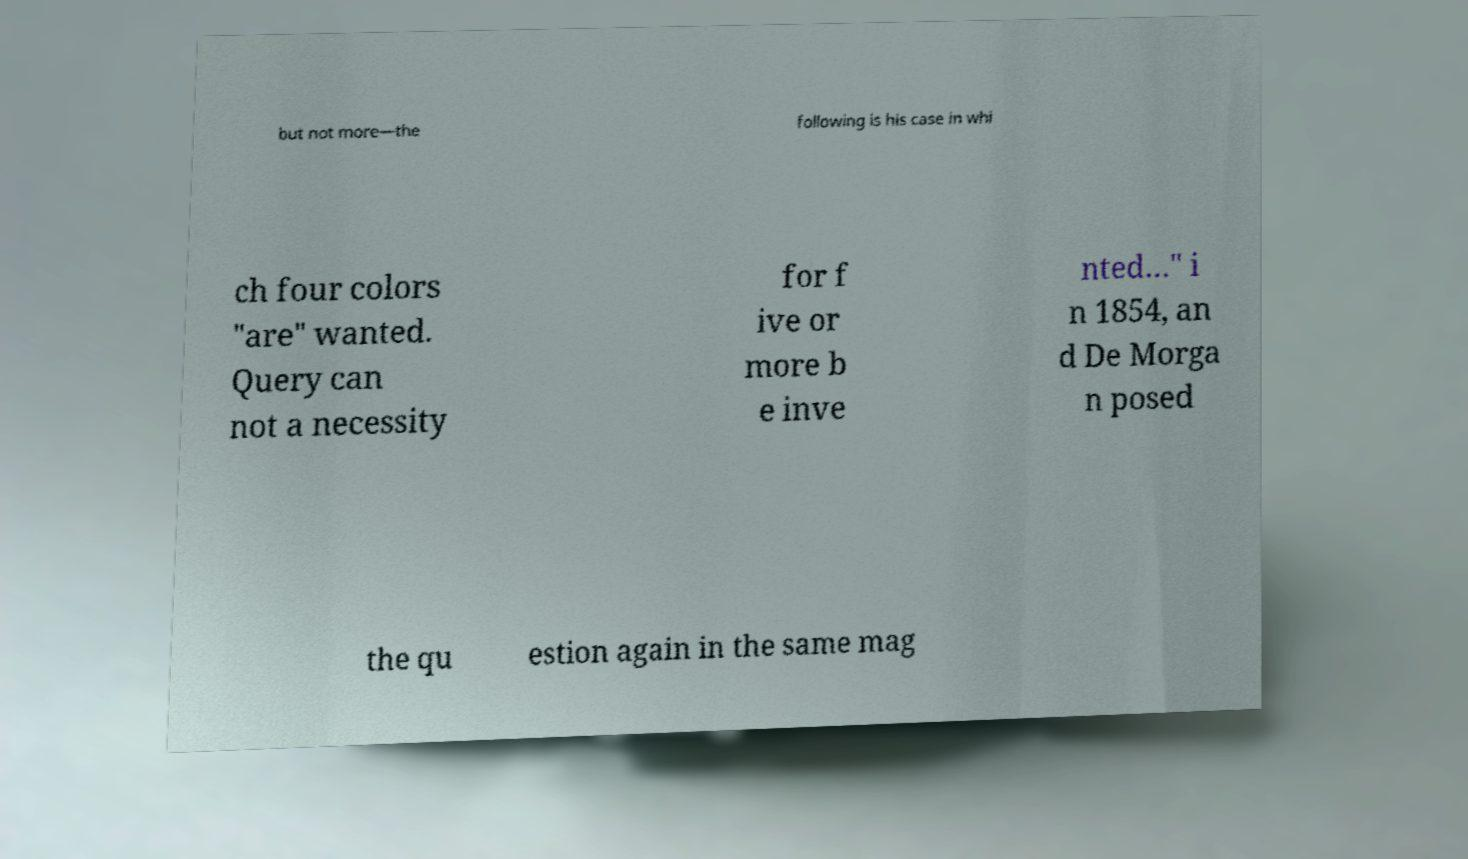I need the written content from this picture converted into text. Can you do that? but not more—the following is his case in whi ch four colors "are" wanted. Query can not a necessity for f ive or more b e inve nted…" i n 1854, an d De Morga n posed the qu estion again in the same mag 